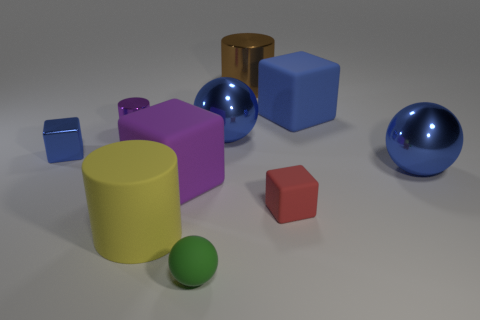Is there a yellow object that has the same material as the small green object?
Your response must be concise. Yes. There is a rubber object that is right of the large yellow matte object and in front of the small red block; what shape is it?
Ensure brevity in your answer.  Sphere. How many other objects are the same shape as the small green thing?
Give a very brief answer. 2. The brown thing is what size?
Your answer should be compact. Large. How many things are yellow things or purple cylinders?
Keep it short and to the point. 2. How big is the blue thing on the left side of the purple rubber cube?
Keep it short and to the point. Small. What color is the cube that is both on the right side of the small purple cylinder and to the left of the green matte object?
Your answer should be very brief. Purple. Are the cylinder that is on the right side of the tiny green thing and the purple cylinder made of the same material?
Offer a terse response. Yes. There is a tiny metal block; is its color the same as the block that is on the right side of the tiny red rubber block?
Keep it short and to the point. Yes. There is a tiny ball; are there any tiny purple things in front of it?
Give a very brief answer. No. 